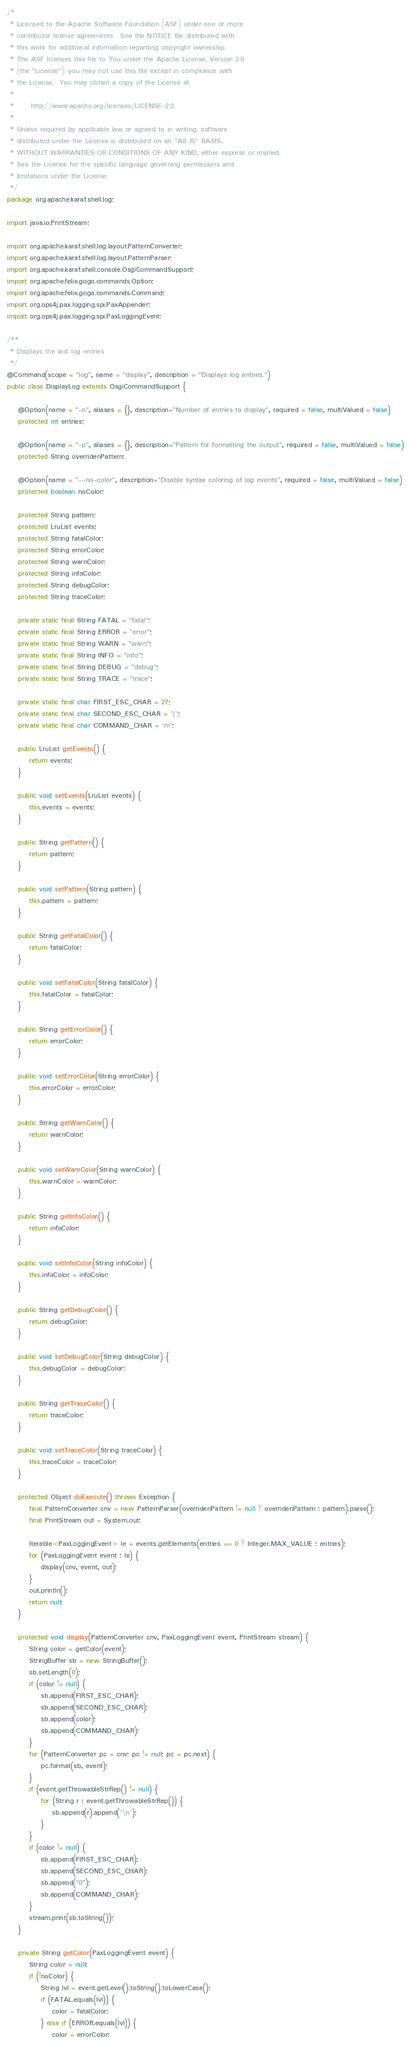Convert code to text. <code><loc_0><loc_0><loc_500><loc_500><_Java_>/*
 * Licensed to the Apache Software Foundation (ASF) under one or more
 * contributor license agreements.  See the NOTICE file distributed with
 * this work for additional information regarding copyright ownership.
 * The ASF licenses this file to You under the Apache License, Version 2.0
 * (the "License"); you may not use this file except in compliance with
 * the License.  You may obtain a copy of the License at
 *
 *      http://www.apache.org/licenses/LICENSE-2.0
 *
 * Unless required by applicable law or agreed to in writing, software
 * distributed under the License is distributed on an "AS IS" BASIS,
 * WITHOUT WARRANTIES OR CONDITIONS OF ANY KIND, either express or implied.
 * See the License for the specific language governing permissions and
 * limitations under the License.
 */
package org.apache.karaf.shell.log;

import java.io.PrintStream;

import org.apache.karaf.shell.log.layout.PatternConverter;
import org.apache.karaf.shell.log.layout.PatternParser;
import org.apache.karaf.shell.console.OsgiCommandSupport;
import org.apache.felix.gogo.commands.Option;
import org.apache.felix.gogo.commands.Command;
import org.ops4j.pax.logging.spi.PaxAppender;
import org.ops4j.pax.logging.spi.PaxLoggingEvent;

/**
 * Displays the last log entries
 */
@Command(scope = "log", name = "display", description = "Displays log entries.")
public class DisplayLog extends OsgiCommandSupport {

    @Option(name = "-n", aliases = {}, description="Number of entries to display", required = false, multiValued = false)
    protected int entries;

    @Option(name = "-p", aliases = {}, description="Pattern for formatting the output", required = false, multiValued = false)
    protected String overridenPattern;

    @Option(name = "--no-color", description="Disable syntax coloring of log events", required = false, multiValued = false)
    protected boolean noColor;

    protected String pattern;
    protected LruList events;
    protected String fatalColor;
    protected String errorColor;
    protected String warnColor;
    protected String infoColor;
    protected String debugColor;
    protected String traceColor;

    private static final String FATAL = "fatal";
    private static final String ERROR = "error";
    private static final String WARN = "warn";
    private static final String INFO = "info";
    private static final String DEBUG = "debug";
    private static final String TRACE = "trace";

    private static final char FIRST_ESC_CHAR = 27;
	private static final char SECOND_ESC_CHAR = '[';
    private static final char COMMAND_CHAR = 'm';

    public LruList getEvents() {
        return events;
    }

    public void setEvents(LruList events) {
        this.events = events;
    }

    public String getPattern() {
        return pattern;
    }

    public void setPattern(String pattern) {
        this.pattern = pattern;
    }

    public String getFatalColor() {
        return fatalColor;
    }

    public void setFatalColor(String fatalColor) {
        this.fatalColor = fatalColor;
    }

    public String getErrorColor() {
        return errorColor;
    }

    public void setErrorColor(String errorColor) {
        this.errorColor = errorColor;
    }

    public String getWarnColor() {
        return warnColor;
    }

    public void setWarnColor(String warnColor) {
        this.warnColor = warnColor;
    }

    public String getInfoColor() {
        return infoColor;
    }

    public void setInfoColor(String infoColor) {
        this.infoColor = infoColor;
    }

    public String getDebugColor() {
        return debugColor;
    }

    public void setDebugColor(String debugColor) {
        this.debugColor = debugColor;
    }

    public String getTraceColor() {
        return traceColor;
    }

    public void setTraceColor(String traceColor) {
        this.traceColor = traceColor;
    }

    protected Object doExecute() throws Exception {
        final PatternConverter cnv = new PatternParser(overridenPattern != null ? overridenPattern : pattern).parse();
        final PrintStream out = System.out;

        Iterable<PaxLoggingEvent> le = events.getElements(entries == 0 ? Integer.MAX_VALUE : entries);
        for (PaxLoggingEvent event : le) {
            display(cnv, event, out);
        }
        out.println();
        return null;
    }

    protected void display(PatternConverter cnv, PaxLoggingEvent event, PrintStream stream) {
        String color = getColor(event);
        StringBuffer sb = new StringBuffer();
        sb.setLength(0);
        if (color != null) {
            sb.append(FIRST_ESC_CHAR);
            sb.append(SECOND_ESC_CHAR);
            sb.append(color);
            sb.append(COMMAND_CHAR);
        }
        for (PatternConverter pc = cnv; pc != null; pc = pc.next) {
            pc.format(sb, event);
        }
        if (event.getThrowableStrRep() != null) {
            for (String r : event.getThrowableStrRep()) {
                sb.append(r).append('\n');
            }
        }
        if (color != null) {
            sb.append(FIRST_ESC_CHAR);
            sb.append(SECOND_ESC_CHAR);
            sb.append("0");
            sb.append(COMMAND_CHAR);
        }
        stream.print(sb.toString());
    }

    private String getColor(PaxLoggingEvent event) {
        String color = null;
        if (!noColor) {
            String lvl = event.getLevel().toString().toLowerCase();
            if (FATAL.equals(lvl)) {
                color = fatalColor;
            } else if (ERROR.equals(lvl)) {
                color = errorColor;</code> 